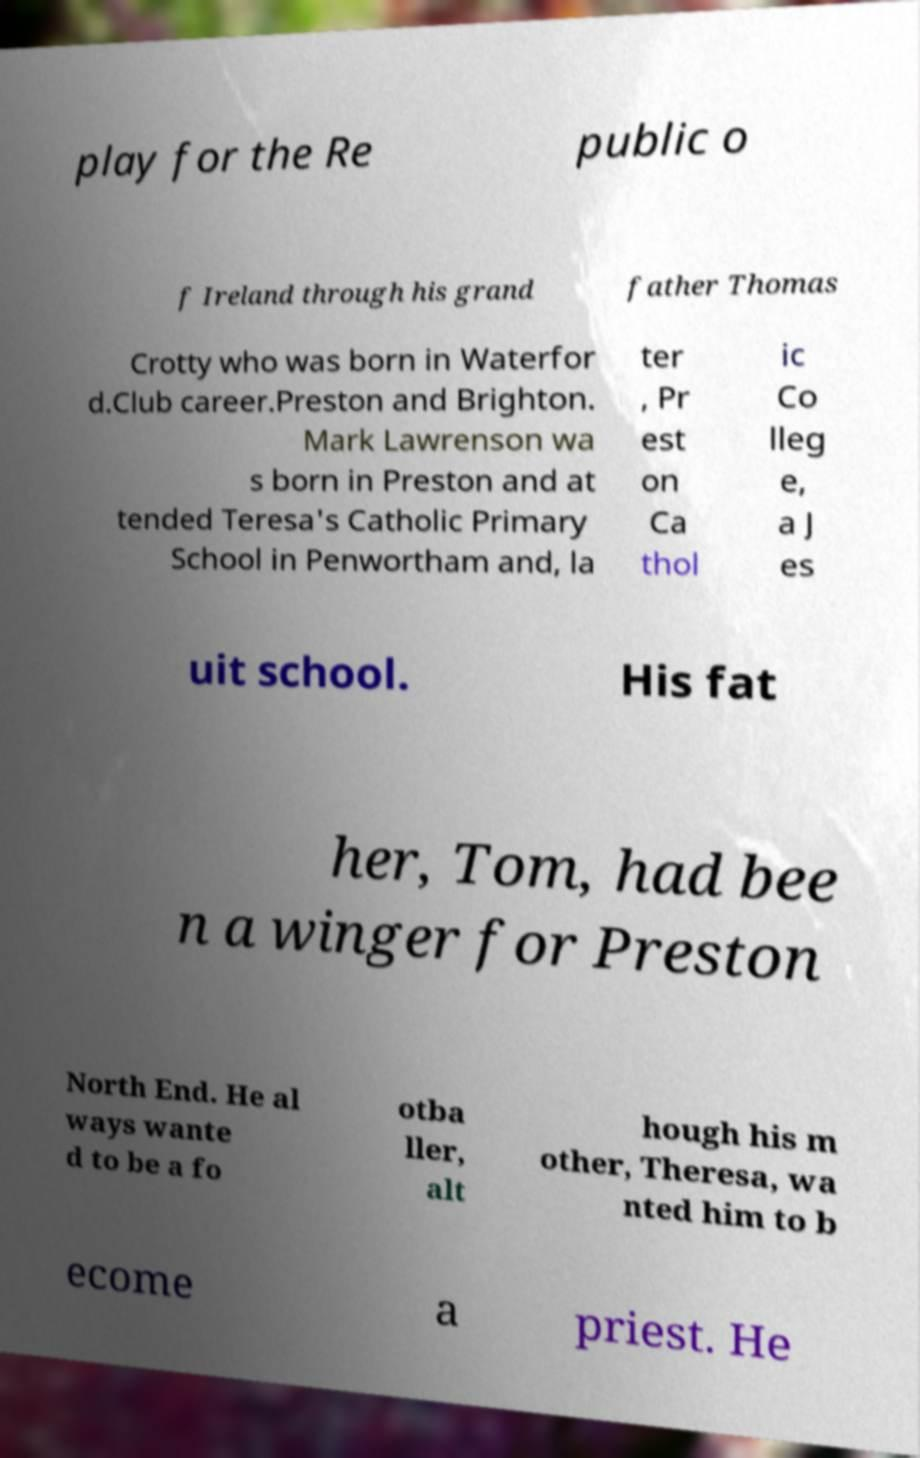Please identify and transcribe the text found in this image. play for the Re public o f Ireland through his grand father Thomas Crotty who was born in Waterfor d.Club career.Preston and Brighton. Mark Lawrenson wa s born in Preston and at tended Teresa's Catholic Primary School in Penwortham and, la ter , Pr est on Ca thol ic Co lleg e, a J es uit school. His fat her, Tom, had bee n a winger for Preston North End. He al ways wante d to be a fo otba ller, alt hough his m other, Theresa, wa nted him to b ecome a priest. He 